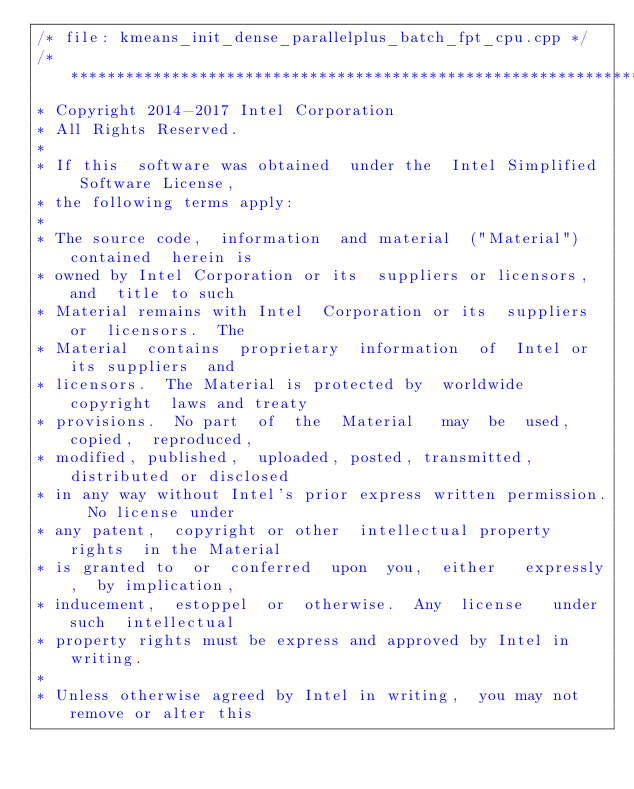<code> <loc_0><loc_0><loc_500><loc_500><_C++_>/* file: kmeans_init_dense_parallelplus_batch_fpt_cpu.cpp */
/*******************************************************************************
* Copyright 2014-2017 Intel Corporation
* All Rights Reserved.
*
* If this  software was obtained  under the  Intel Simplified  Software License,
* the following terms apply:
*
* The source code,  information  and material  ("Material") contained  herein is
* owned by Intel Corporation or its  suppliers or licensors,  and  title to such
* Material remains with Intel  Corporation or its  suppliers or  licensors.  The
* Material  contains  proprietary  information  of  Intel or  its suppliers  and
* licensors.  The Material is protected by  worldwide copyright  laws and treaty
* provisions.  No part  of  the  Material   may  be  used,  copied,  reproduced,
* modified, published,  uploaded, posted, transmitted,  distributed or disclosed
* in any way without Intel's prior express written permission.  No license under
* any patent,  copyright or other  intellectual property rights  in the Material
* is granted to  or  conferred  upon  you,  either   expressly,  by implication,
* inducement,  estoppel  or  otherwise.  Any  license   under such  intellectual
* property rights must be express and approved by Intel in writing.
*
* Unless otherwise agreed by Intel in writing,  you may not remove or alter this</code> 